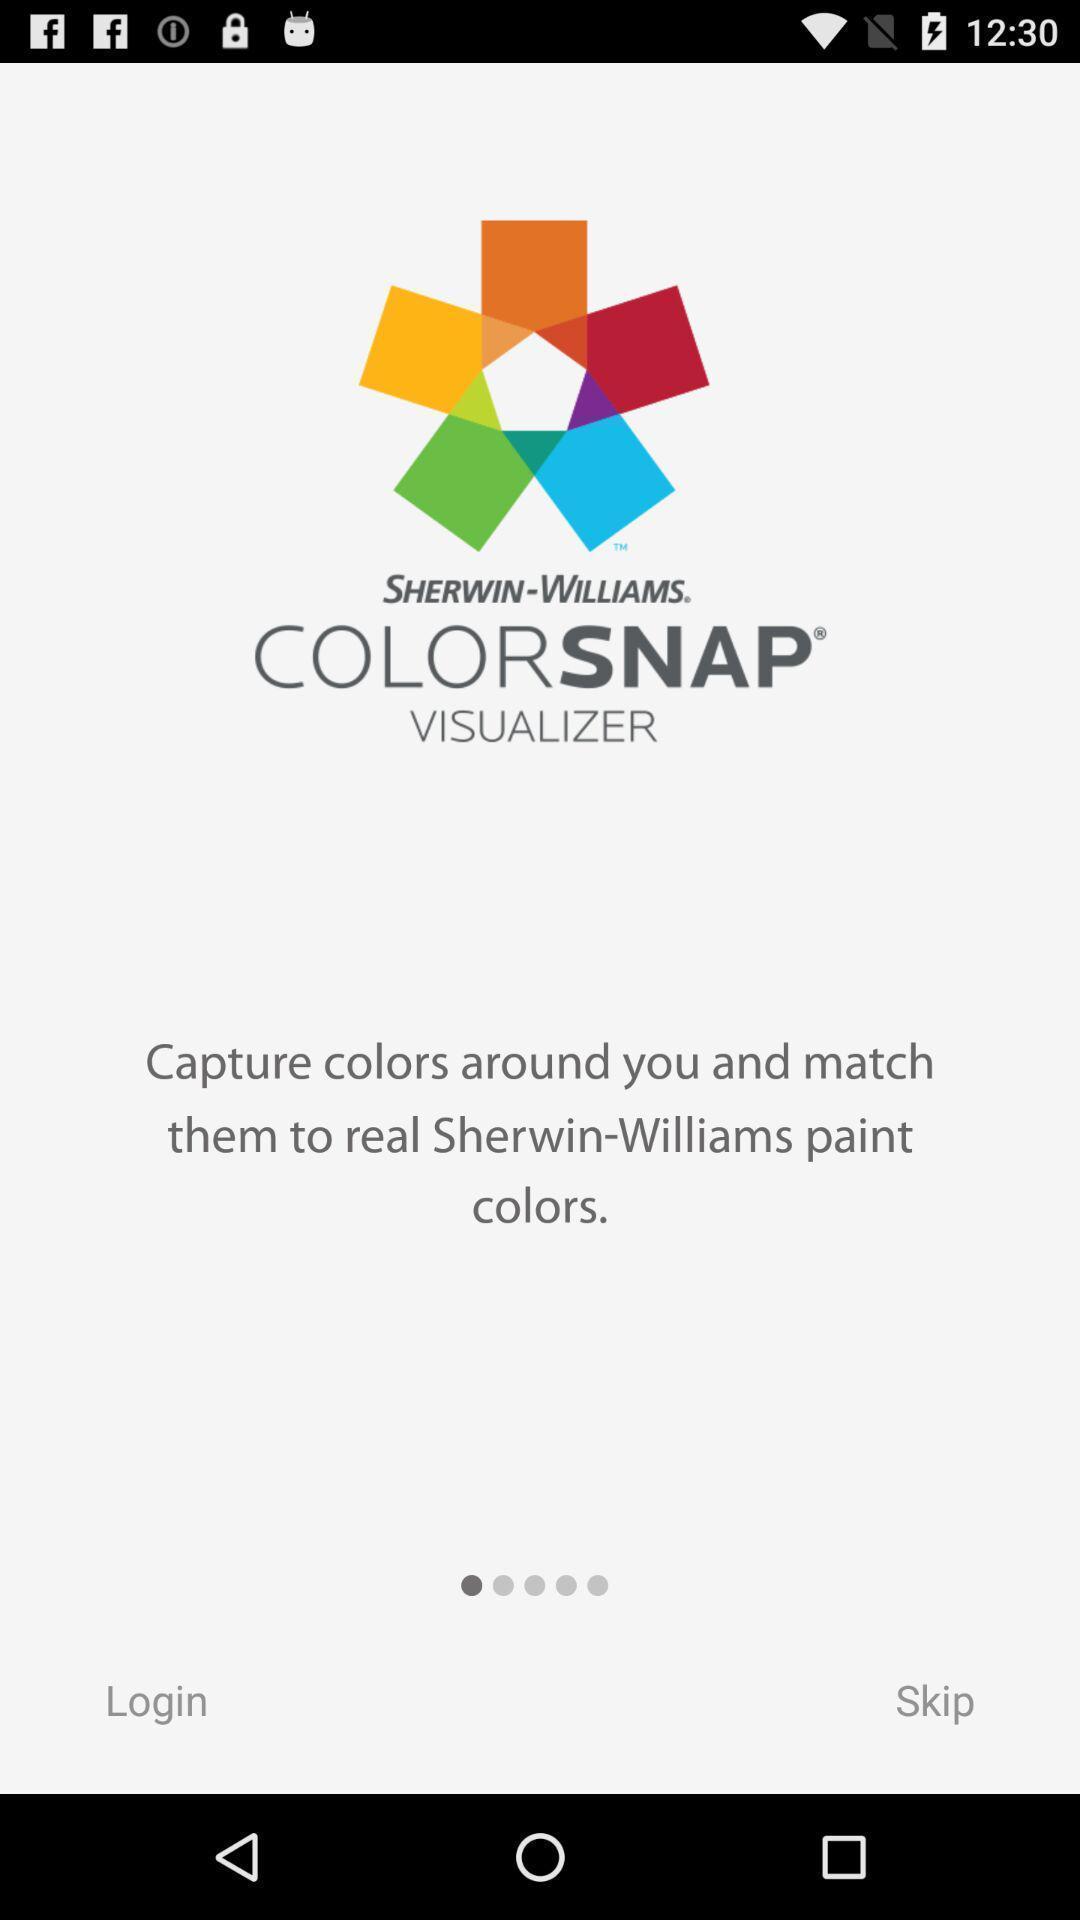Summarize the information in this screenshot. Welcome page of photography app. 